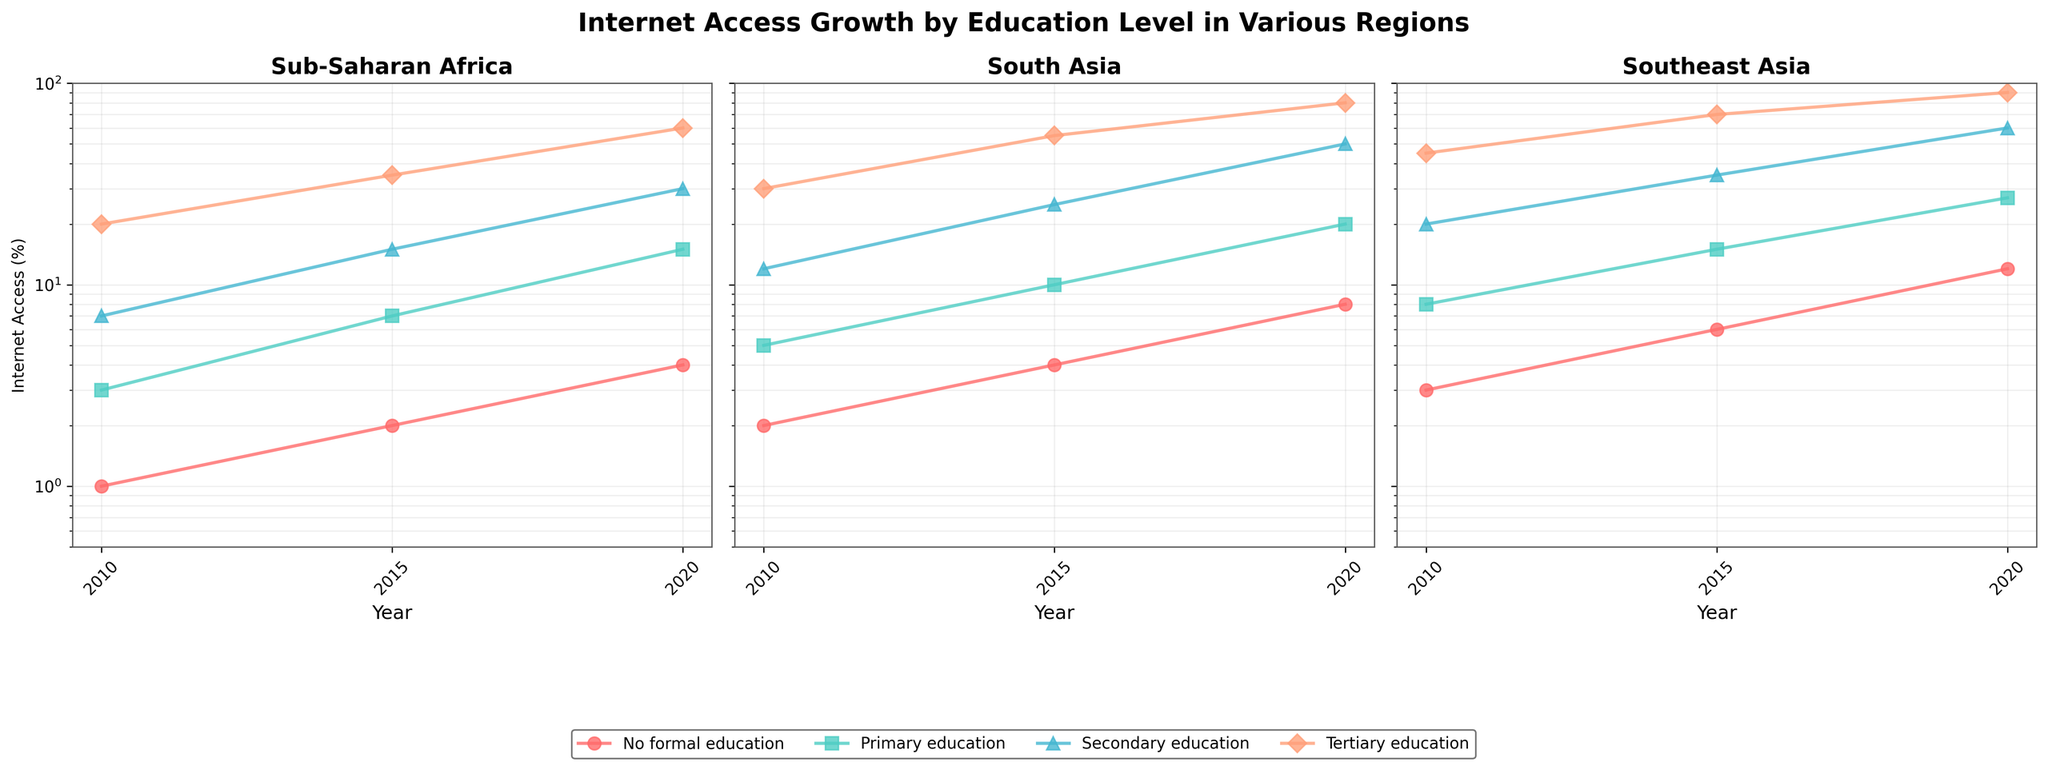What's the overall trend in internet access for individuals with no formal education across all regions? By examining the curves for "No formal education" in each subplot, we see that the percentage of internet access has increased in all regions over time.
Answer: Increasing Which region had the highest internet access rate for people with tertiary education in 2010? We need to look at the data points for tertiary education in all the subplots for the year 2010. The highest percentage is in Southeast Asia, which shows around 45%.
Answer: Southeast Asia In which region did people with secondary education have the most substantial increase in internet access from 2010 to 2020? We calculate the increase by subtracting the 2010 value from the 2020 value for each region's secondary education. Sub-Saharan Africa increased by 23%, South Asia by 38%, and Southeast Asia by 40%. The highest increase is in Southeast Asia.
Answer: Southeast Asia By how much did internet access among those with primary education in South Asia increase between 2015 and 2020? The percentage in 2015 was 10%, and in 2020 it was 20%. The difference is 20% - 10% = 10%.
Answer: 10% Which education level had similar internet access percentages across all regions in 2015? We look at the 2015 data points in all subplots. "Tertiary education" seems to have closest values across all regions, approximately between 35% and 70%.
Answer: Tertiary education Compare the rate of internet access growth for people with secondary education in Sub-Saharan Africa and South Asia from 2010 to 2020. In Sub-Saharan Africa, it increased from 7% to 30% (23% increase). In South Asia, it increased from 12% to 50% (38% increase). Thus, South Asia had a higher growth rate.
Answer: South Asia What is the difference in internet access between primary and secondary education in Southeast Asia in 2020? In 2020 for Southeast Asia, primary education has 27% while secondary education has 60%. The difference is 60% - 27% = 33%.
Answer: 33% How does the internet access growth for people with no formal education compare between Sub-Saharan Africa and Southeast Asia over the entire period? In Sub-Saharan Africa, the access rate increased from 1% to 4% (3% increase). In Southeast Asia, it increased from 3% to 12% (9% increase). Southeast Asia showed a more significant increase.
Answer: Southeast Asia What's the trend for internet access in South Asia for tertiary education from 2010 to 2020, and what could this imply? The data shows an increase from 30% in 2010 to 80% in 2020. This implies a significant improvement in internet accessibility for higher-educated individuals in South Asia over the decade.
Answer: Significant improvement 